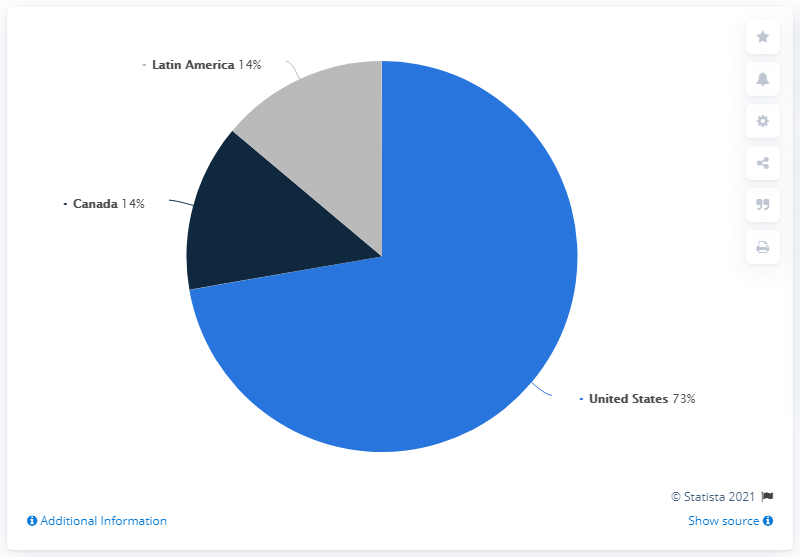Specify some key components in this picture. Canada is the second largest country in terms of sales share in [Latin America]. The ratio of the United States to Canada is approximately 5.214. 